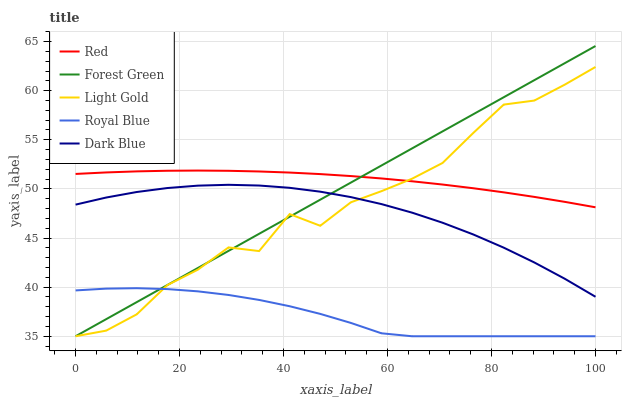Does Forest Green have the minimum area under the curve?
Answer yes or no. No. Does Forest Green have the maximum area under the curve?
Answer yes or no. No. Is Light Gold the smoothest?
Answer yes or no. No. Is Forest Green the roughest?
Answer yes or no. No. Does Red have the lowest value?
Answer yes or no. No. Does Light Gold have the highest value?
Answer yes or no. No. Is Royal Blue less than Red?
Answer yes or no. Yes. Is Red greater than Royal Blue?
Answer yes or no. Yes. Does Royal Blue intersect Red?
Answer yes or no. No. 